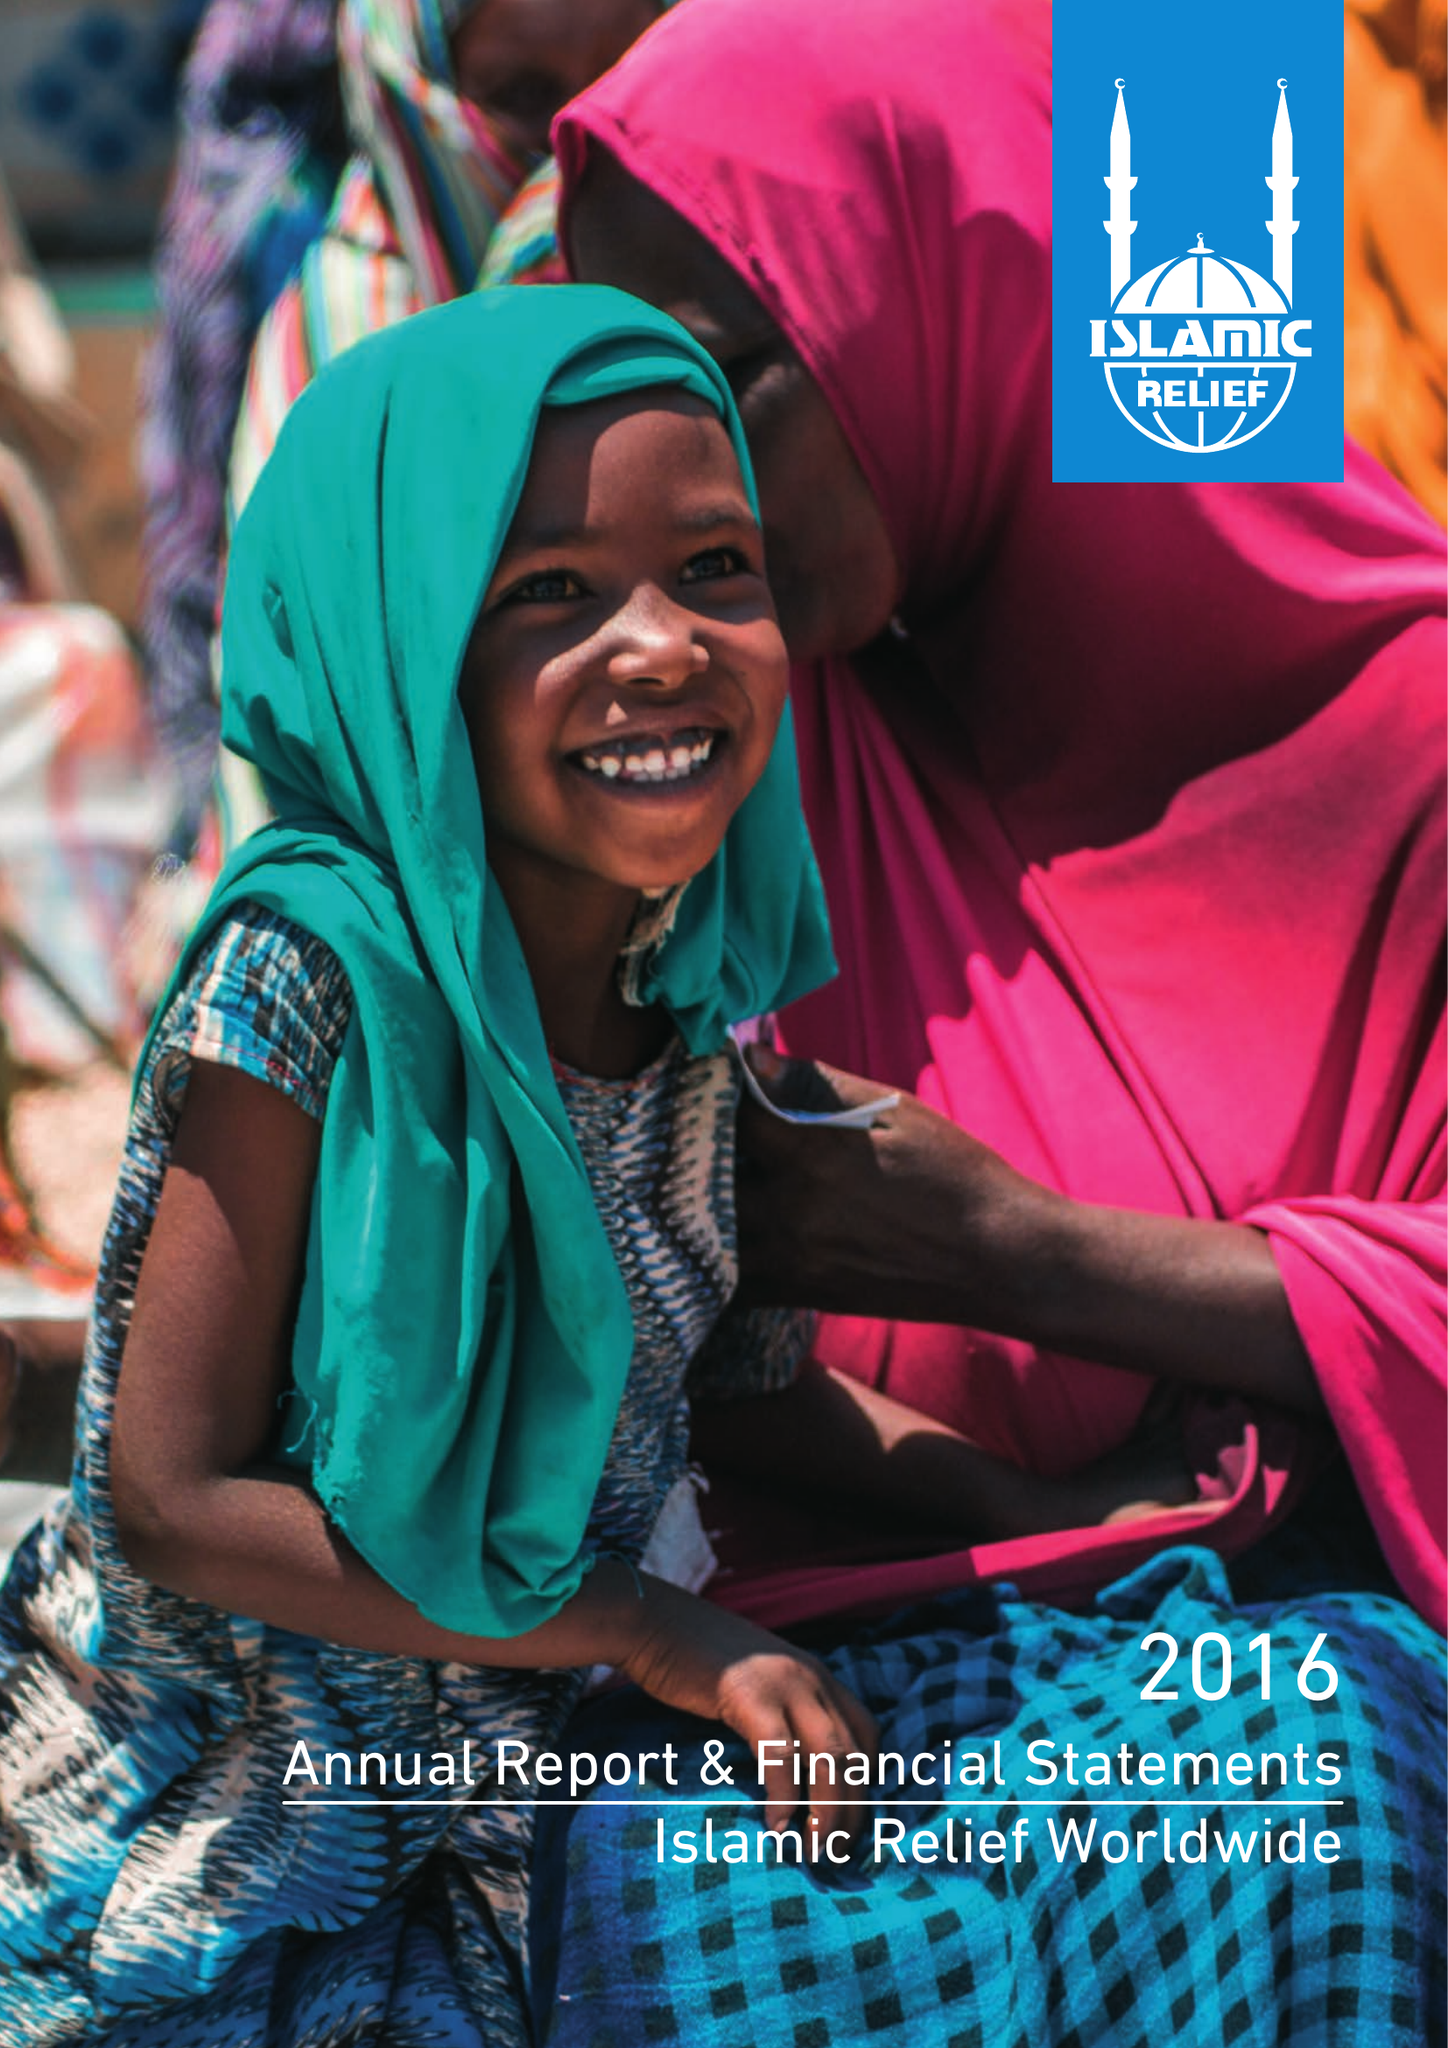What is the value for the report_date?
Answer the question using a single word or phrase. 2016-12-31 